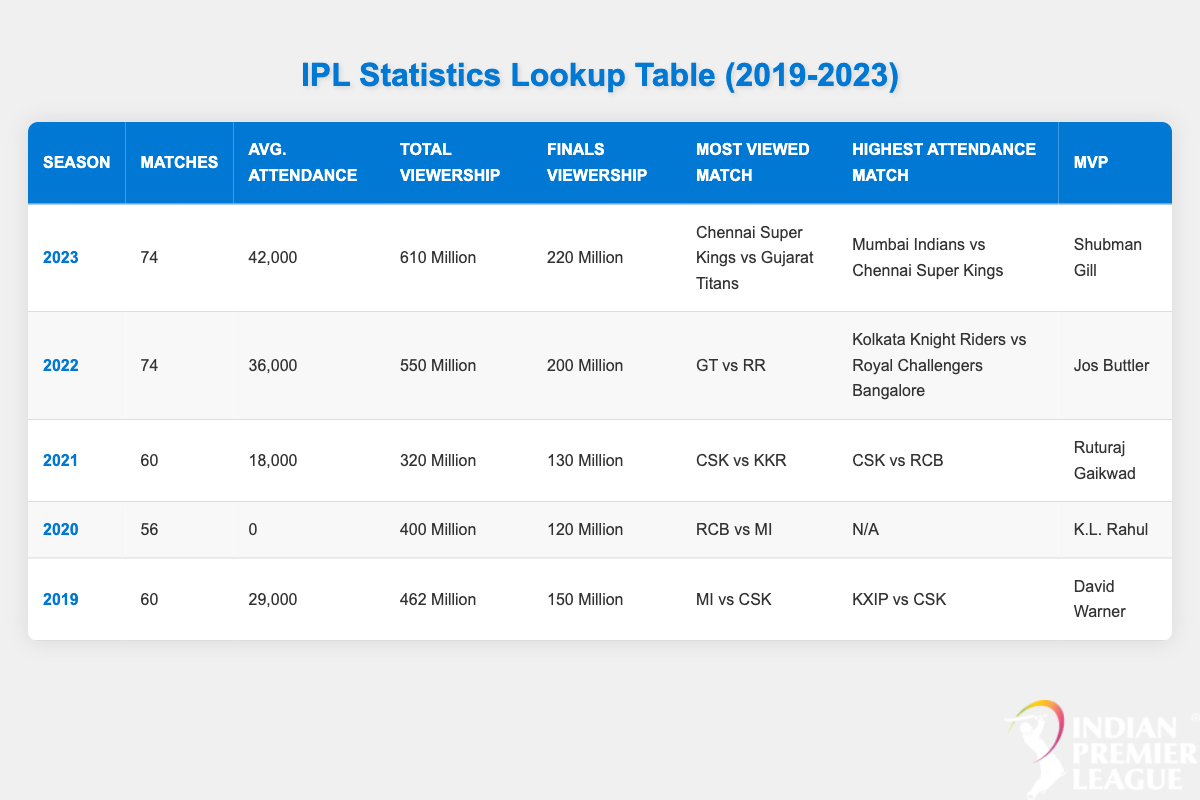What was the total viewership of IPL matches in 2022? The table shows that the total viewership for the 2022 season is listed as 550 Million.
Answer: 550 Million Which season had the highest average attendance? By comparing the average attendance values for each season, 2023 has an average attendance of 42,000, which is greater than all other seasons.
Answer: 2023 Did the average attendance increase from 2021 to 2022? The average attendance in 2021 was 18,000 and in 2022 it was 36,000. Since 36,000 is greater than 18,000, it indicates that attendance did increase.
Answer: Yes What was the finals viewership in 2020, and how does it compare to the finals viewership in 2023? The finals viewership in 2020 was 120 Million, and in 2023 it was 220 Million. Comparing the two values shows that 220 Million is greater than 120 Million, indicating an increase.
Answer: 120 Million (lower than 2023) What is the difference in total viewership between the years 2019 and 2021? The total viewership in 2019 was 462 Million, while in 2021 it was 320 Million. To find the difference, we subtract 320 Million from 462 Million, which gives us 142 Million.
Answer: 142 Million Which player was the MVP for the 2021 season, and how many matches were played that season? The MVP for the 2021 season is listed as Ruturaj Gaikwad, and the number of matches played that season was 60, as per the season's row in the table.
Answer: Ruturaj Gaikwad, 60 Is it true that the most viewed match of 2020 was between RCB and MI? The table indicates that the most viewed match in 2020 is indeed RCB vs MI, confirming the statement's accuracy.
Answer: Yes How many matches were played in the 2022 season, and what was the average attendance for that season? The table states that there were 74 matches played in the 2022 season, and the average attendance was 36,000, providing two specific pieces of data regarding the season.
Answer: 74 matches, 36,000 average attendance Was the total viewership in 2020 greater than 300 Million? The total viewership in 2020 was 400 Million, which is indeed greater than 300 Million, validating the statement.
Answer: Yes 